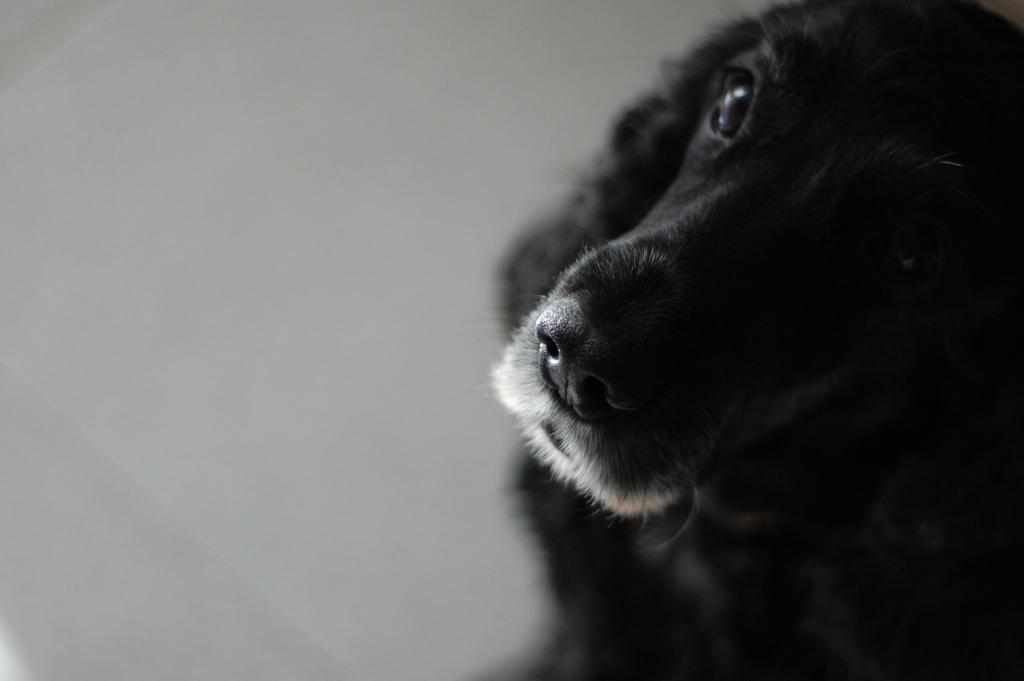What type of animal is present in the image? There is a dog in the image. What color is the background of the image? The background of the image is white. Where is the hen located in the image? There is no hen present in the image. What type of statement can be seen written on the wall in the image? There is no statement visible in the image. What type of playground equipment can be seen in the image? There is no playground equipment present in the image. 